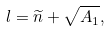<formula> <loc_0><loc_0><loc_500><loc_500>l = \widetilde { n } + \sqrt { A _ { 1 } } ,</formula> 